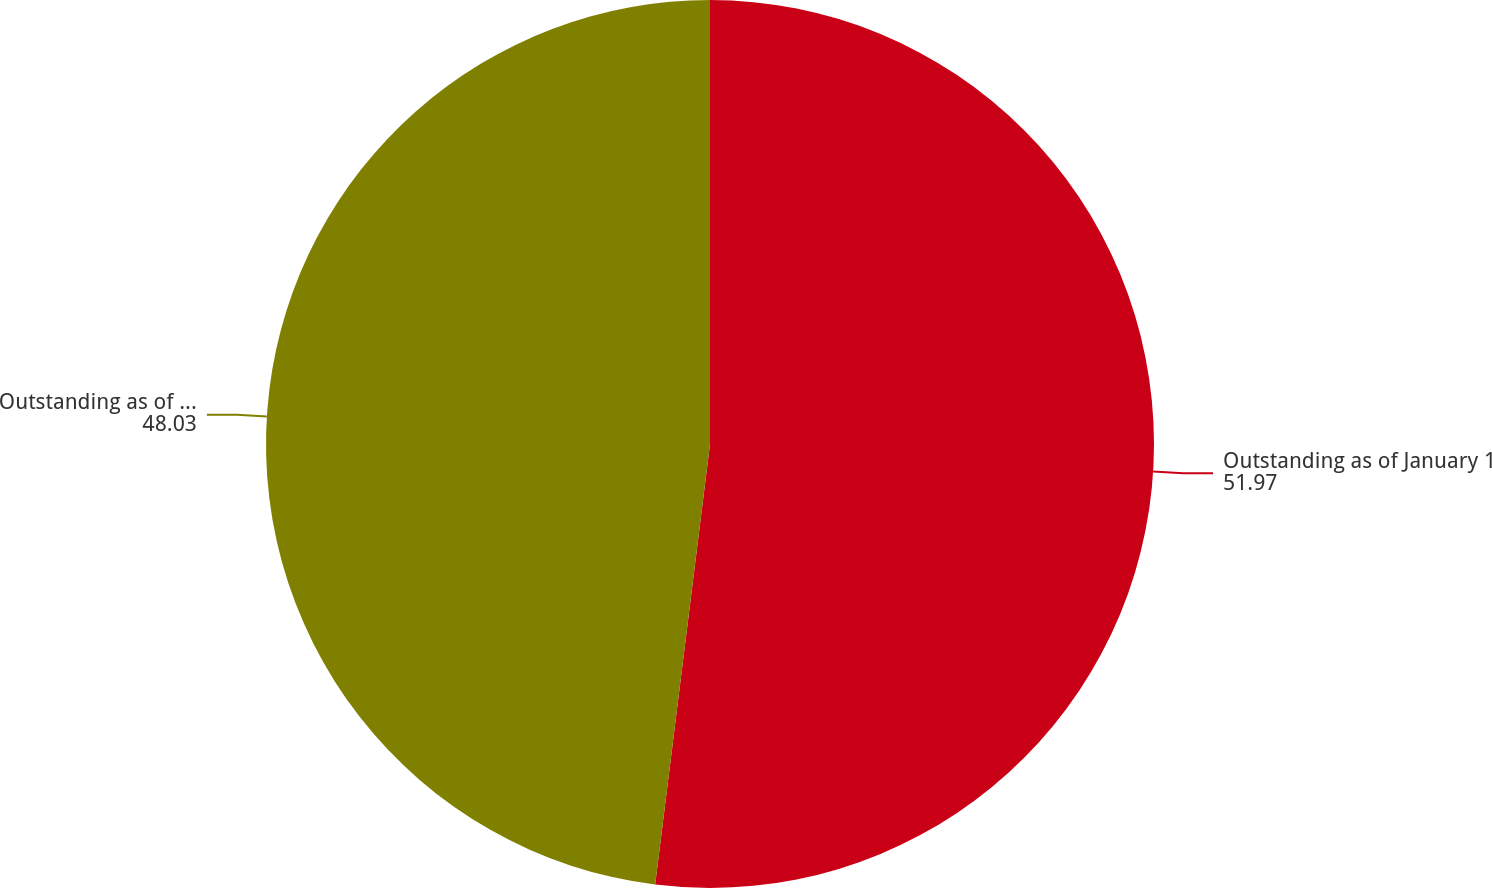Convert chart. <chart><loc_0><loc_0><loc_500><loc_500><pie_chart><fcel>Outstanding as of January 1<fcel>Outstanding as of December 31<nl><fcel>51.97%<fcel>48.03%<nl></chart> 